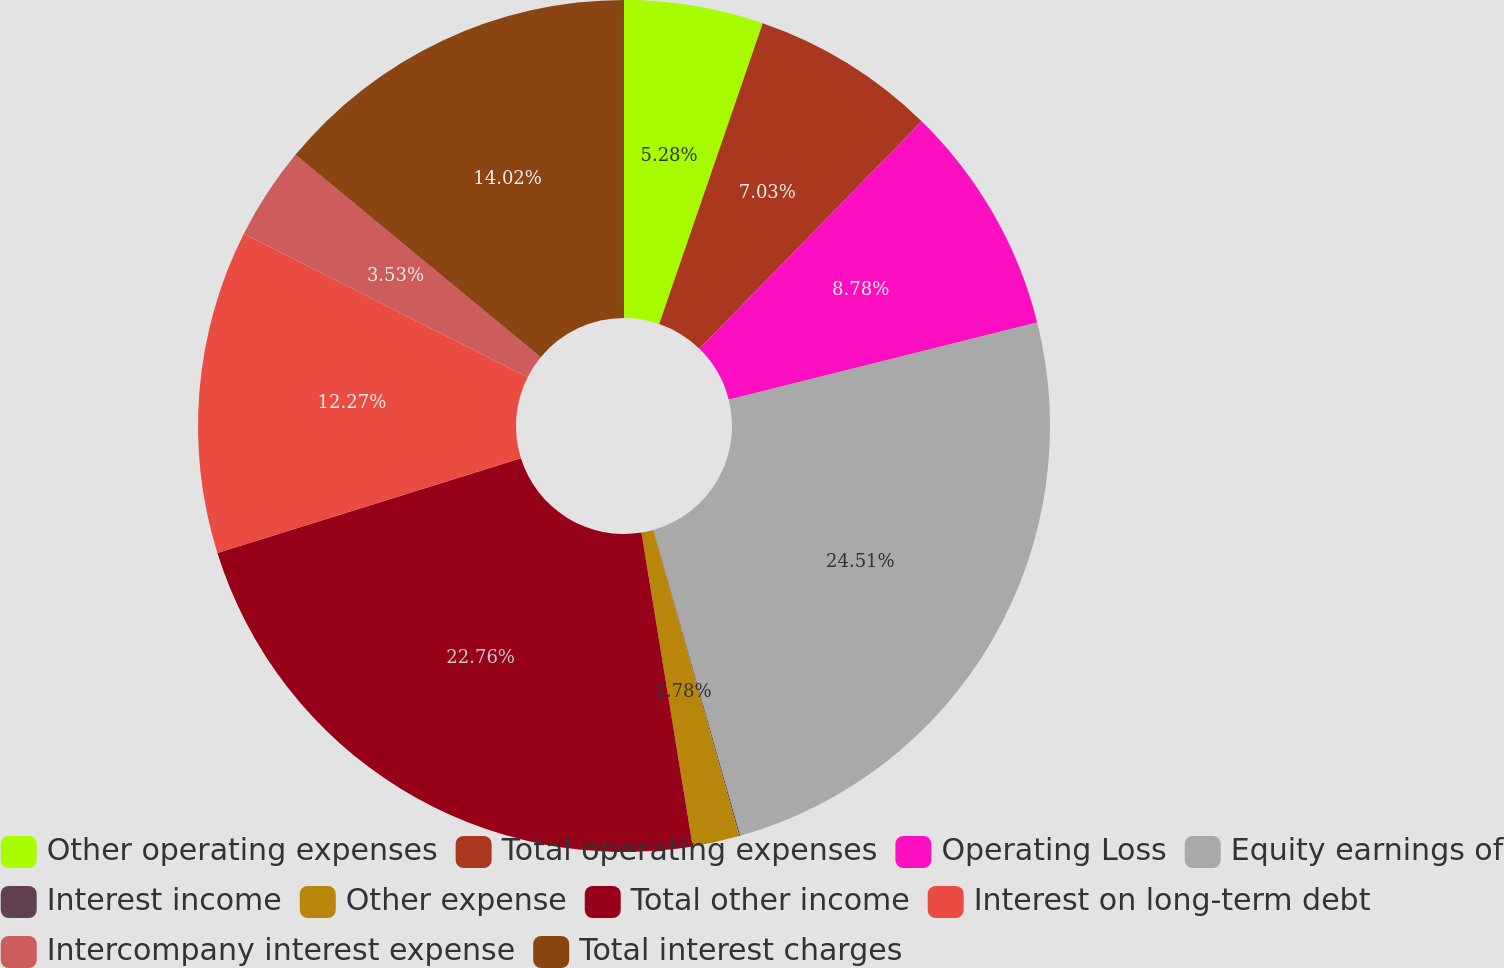Convert chart. <chart><loc_0><loc_0><loc_500><loc_500><pie_chart><fcel>Other operating expenses<fcel>Total operating expenses<fcel>Operating Loss<fcel>Equity earnings of<fcel>Interest income<fcel>Other expense<fcel>Total other income<fcel>Interest on long-term debt<fcel>Intercompany interest expense<fcel>Total interest charges<nl><fcel>5.28%<fcel>7.03%<fcel>8.78%<fcel>24.51%<fcel>0.04%<fcel>1.78%<fcel>22.76%<fcel>12.27%<fcel>3.53%<fcel>14.02%<nl></chart> 